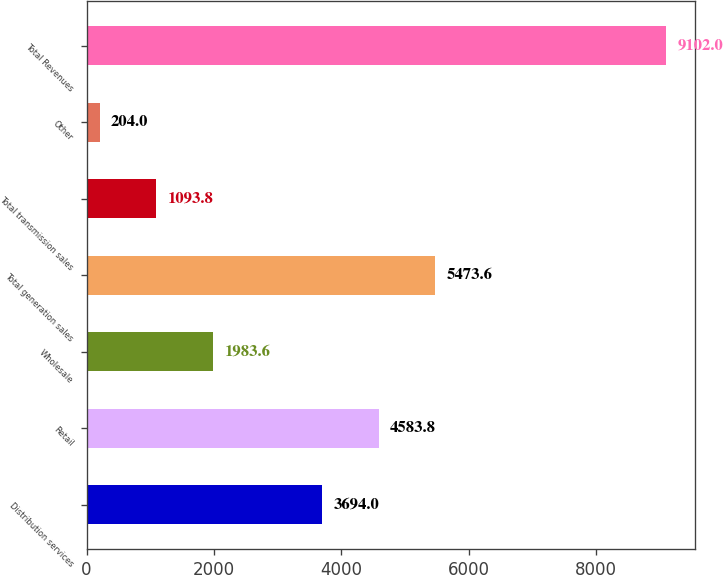<chart> <loc_0><loc_0><loc_500><loc_500><bar_chart><fcel>Distribution services<fcel>Retail<fcel>Wholesale<fcel>Total generation sales<fcel>Total transmission sales<fcel>Other<fcel>Total Revenues<nl><fcel>3694<fcel>4583.8<fcel>1983.6<fcel>5473.6<fcel>1093.8<fcel>204<fcel>9102<nl></chart> 